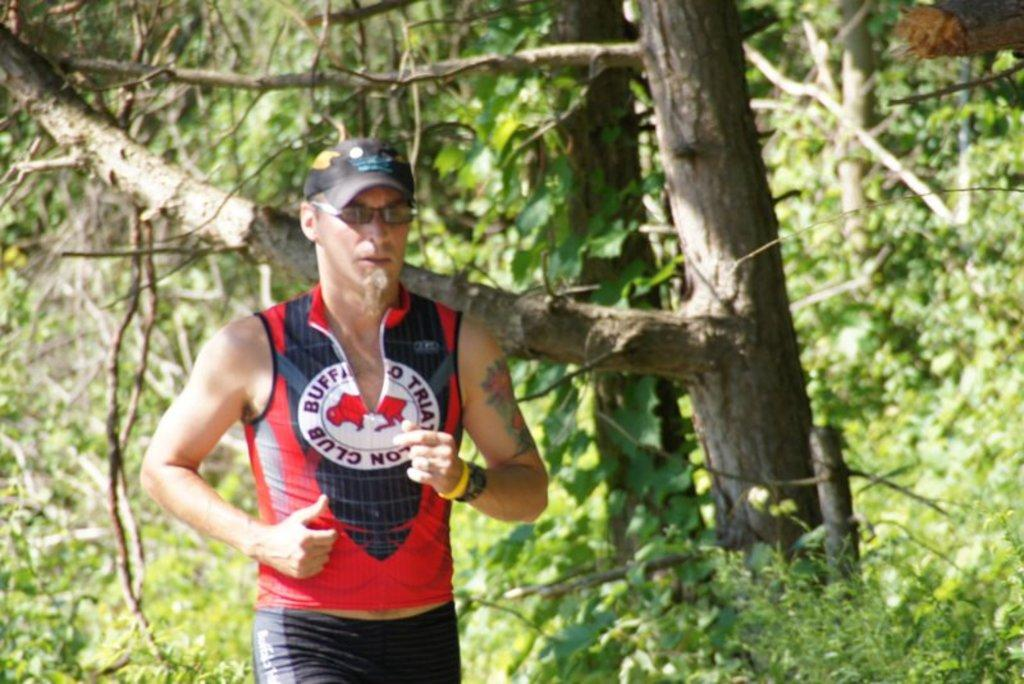<image>
Write a terse but informative summary of the picture. A runner has the word club on his shirt. 